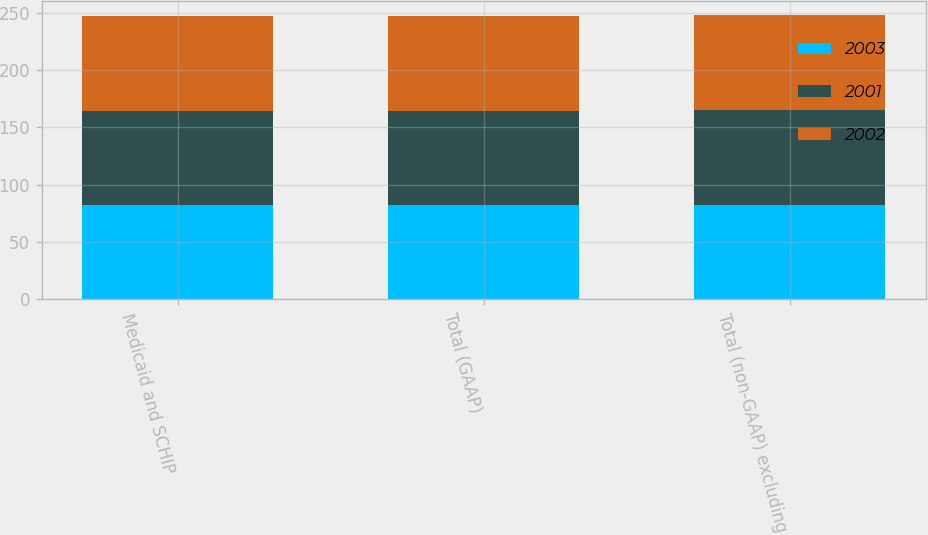Convert chart. <chart><loc_0><loc_0><loc_500><loc_500><stacked_bar_chart><ecel><fcel>Medicaid and SCHIP<fcel>Total (GAAP)<fcel>Total (non-GAAP) excluding<nl><fcel>2003<fcel>82.5<fcel>82.4<fcel>82.6<nl><fcel>2001<fcel>82.2<fcel>82.3<fcel>82.3<nl><fcel>2002<fcel>82.8<fcel>82.8<fcel>82.8<nl></chart> 